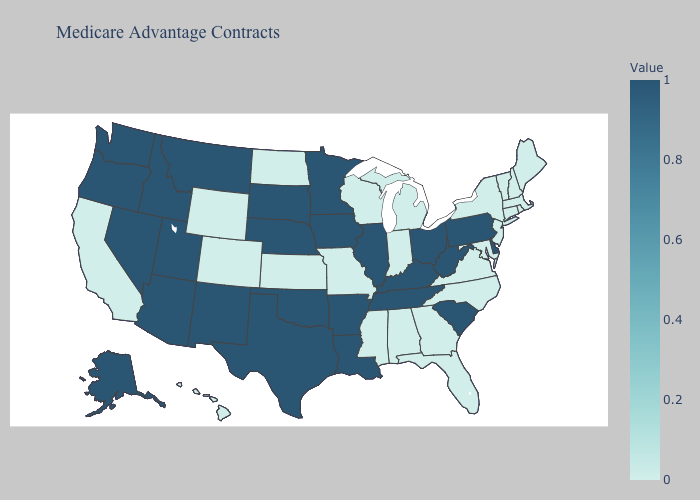Does North Carolina have the highest value in the USA?
Be succinct. No. Does the map have missing data?
Write a very short answer. No. Is the legend a continuous bar?
Short answer required. Yes. Does North Carolina have a higher value than Oregon?
Write a very short answer. No. Does Indiana have the lowest value in the MidWest?
Answer briefly. Yes. Which states have the lowest value in the Northeast?
Answer briefly. Connecticut, Massachusetts, Maine, New Hampshire, New Jersey, New York, Rhode Island, Vermont. Does the map have missing data?
Answer briefly. No. Among the states that border Ohio , does West Virginia have the highest value?
Give a very brief answer. Yes. Is the legend a continuous bar?
Be succinct. Yes. 